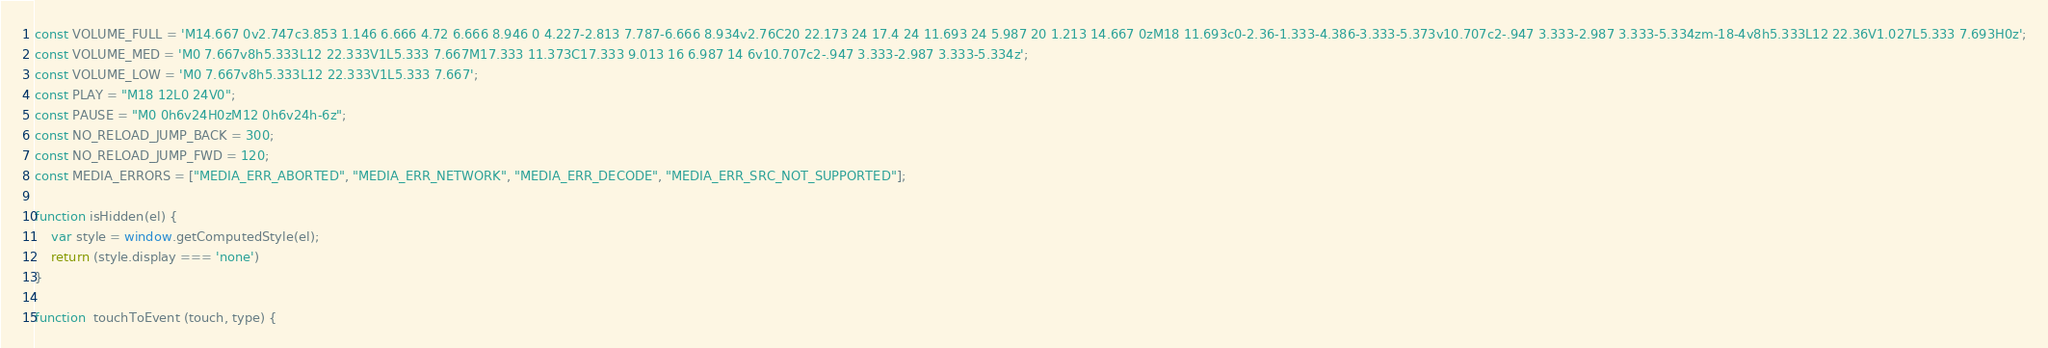<code> <loc_0><loc_0><loc_500><loc_500><_JavaScript_>
const VOLUME_FULL = 'M14.667 0v2.747c3.853 1.146 6.666 4.72 6.666 8.946 0 4.227-2.813 7.787-6.666 8.934v2.76C20 22.173 24 17.4 24 11.693 24 5.987 20 1.213 14.667 0zM18 11.693c0-2.36-1.333-4.386-3.333-5.373v10.707c2-.947 3.333-2.987 3.333-5.334zm-18-4v8h5.333L12 22.36V1.027L5.333 7.693H0z';
const VOLUME_MED = 'M0 7.667v8h5.333L12 22.333V1L5.333 7.667M17.333 11.373C17.333 9.013 16 6.987 14 6v10.707c2-.947 3.333-2.987 3.333-5.334z';
const VOLUME_LOW = 'M0 7.667v8h5.333L12 22.333V1L5.333 7.667';
const PLAY = "M18 12L0 24V0";
const PAUSE = "M0 0h6v24H0zM12 0h6v24h-6z";
const NO_RELOAD_JUMP_BACK = 300;
const NO_RELOAD_JUMP_FWD = 120;
const MEDIA_ERRORS = ["MEDIA_ERR_ABORTED", "MEDIA_ERR_NETWORK", "MEDIA_ERR_DECODE", "MEDIA_ERR_SRC_NOT_SUPPORTED"];

function isHidden(el) {
    var style = window.getComputedStyle(el);
    return (style.display === 'none')
}

function  touchToEvent (touch, type) {</code> 